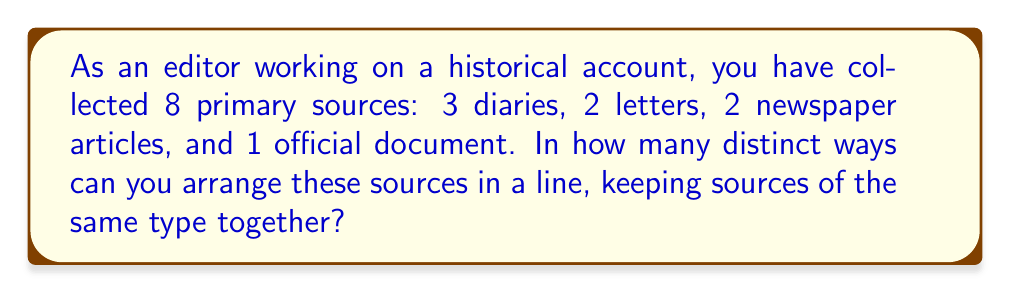Show me your answer to this math problem. To solve this problem, we'll use the concept of permutations with repetition from group theory. Here's the step-by-step solution:

1) First, we need to consider the sources as groups:
   - Diaries (3)
   - Letters (2)
   - Newspaper articles (2)
   - Official document (1)

2) We're arranging these 4 groups, so we start with 4! permutations.

3) However, within the groups of diaries, letters, and newspaper articles, we have repeated elements. We need to account for these:
   - For diaries: 3! ways
   - For letters: 2! ways
   - For newspaper articles: 2! ways

4) Using the multiplication principle and division for repeated elements, our formula becomes:

   $$\frac{4!}{3! \cdot 2! \cdot 2!}$$

5) Let's calculate:
   $$\frac{4!}{3! \cdot 2! \cdot 2!} = \frac{24}{6 \cdot 2 \cdot 2} = \frac{24}{24} = 1$$

Therefore, there is only 1 distinct way to arrange these sources while keeping sources of the same type together.
Answer: 1 distinct permutation 